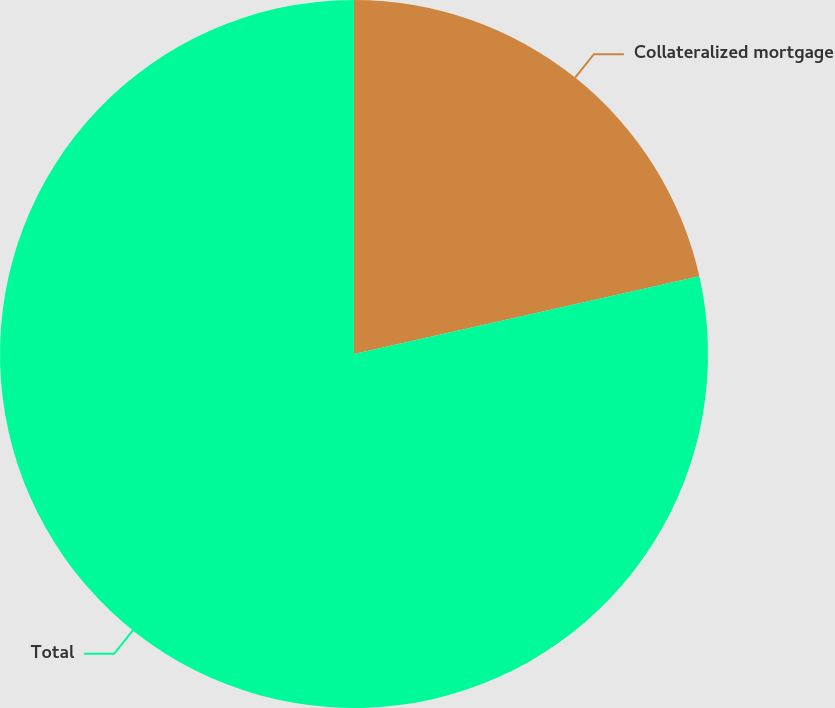Convert chart to OTSL. <chart><loc_0><loc_0><loc_500><loc_500><pie_chart><fcel>Collateralized mortgage<fcel>Total<nl><fcel>21.48%<fcel>78.52%<nl></chart> 